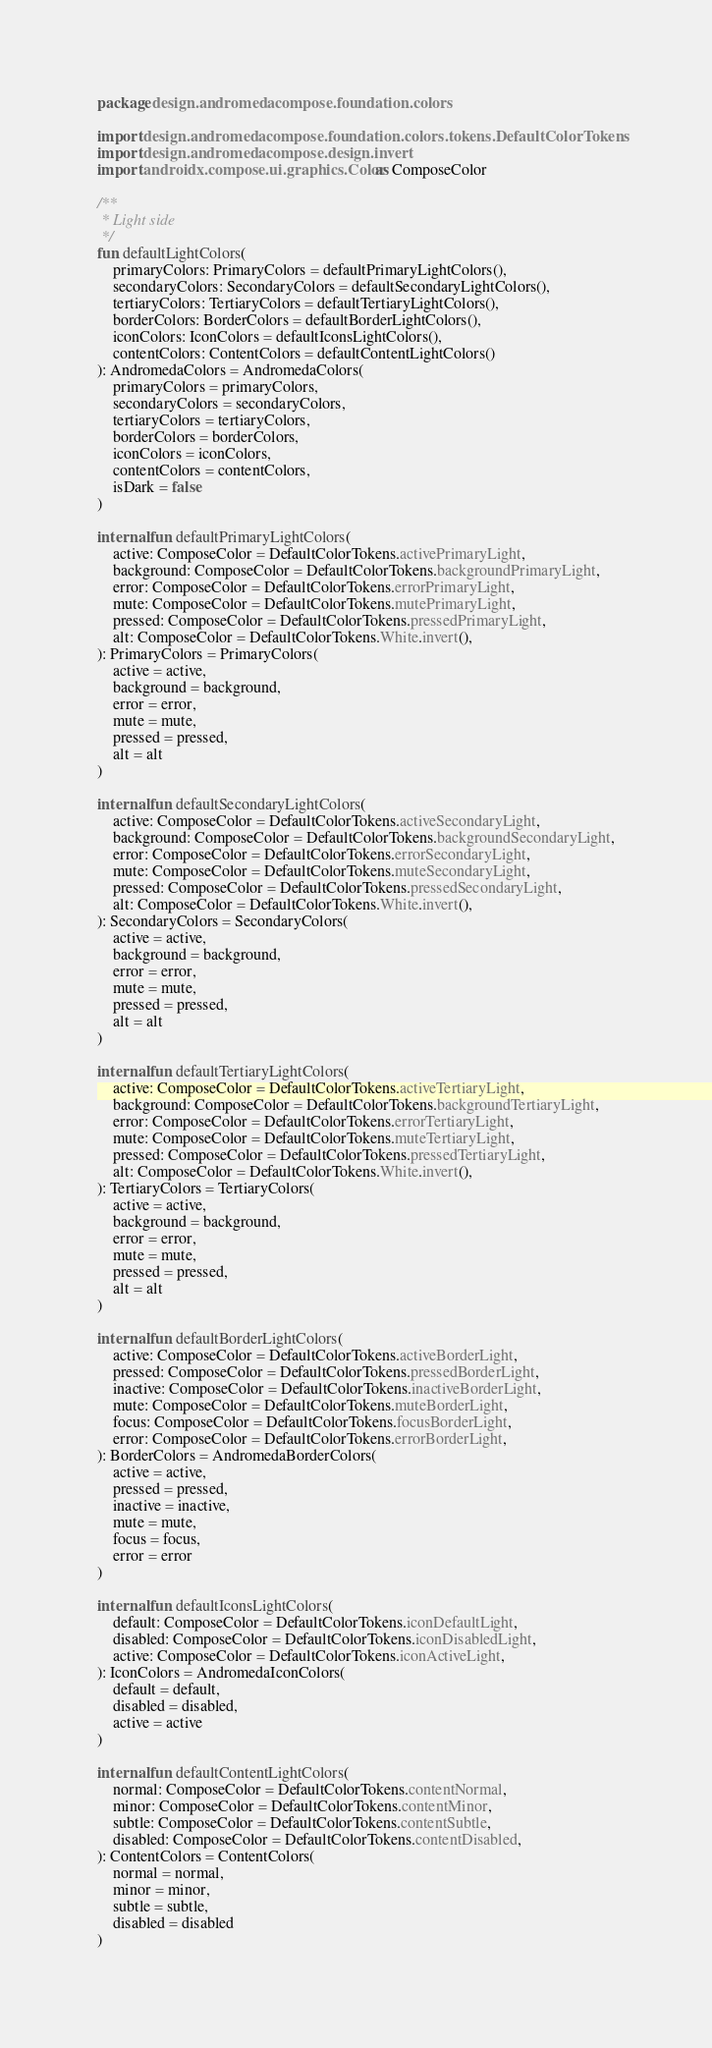<code> <loc_0><loc_0><loc_500><loc_500><_Kotlin_>package design.andromedacompose.foundation.colors

import design.andromedacompose.foundation.colors.tokens.DefaultColorTokens
import design.andromedacompose.design.invert
import androidx.compose.ui.graphics.Color as ComposeColor

/**
 * Light side
 */
fun defaultLightColors(
    primaryColors: PrimaryColors = defaultPrimaryLightColors(),
    secondaryColors: SecondaryColors = defaultSecondaryLightColors(),
    tertiaryColors: TertiaryColors = defaultTertiaryLightColors(),
    borderColors: BorderColors = defaultBorderLightColors(),
    iconColors: IconColors = defaultIconsLightColors(),
    contentColors: ContentColors = defaultContentLightColors()
): AndromedaColors = AndromedaColors(
    primaryColors = primaryColors,
    secondaryColors = secondaryColors,
    tertiaryColors = tertiaryColors,
    borderColors = borderColors,
    iconColors = iconColors,
    contentColors = contentColors,
    isDark = false
)

internal fun defaultPrimaryLightColors(
    active: ComposeColor = DefaultColorTokens.activePrimaryLight,
    background: ComposeColor = DefaultColorTokens.backgroundPrimaryLight,
    error: ComposeColor = DefaultColorTokens.errorPrimaryLight,
    mute: ComposeColor = DefaultColorTokens.mutePrimaryLight,
    pressed: ComposeColor = DefaultColorTokens.pressedPrimaryLight,
    alt: ComposeColor = DefaultColorTokens.White.invert(),
): PrimaryColors = PrimaryColors(
    active = active,
    background = background,
    error = error,
    mute = mute,
    pressed = pressed,
    alt = alt
)

internal fun defaultSecondaryLightColors(
    active: ComposeColor = DefaultColorTokens.activeSecondaryLight,
    background: ComposeColor = DefaultColorTokens.backgroundSecondaryLight,
    error: ComposeColor = DefaultColorTokens.errorSecondaryLight,
    mute: ComposeColor = DefaultColorTokens.muteSecondaryLight,
    pressed: ComposeColor = DefaultColorTokens.pressedSecondaryLight,
    alt: ComposeColor = DefaultColorTokens.White.invert(),
): SecondaryColors = SecondaryColors(
    active = active,
    background = background,
    error = error,
    mute = mute,
    pressed = pressed,
    alt = alt
)

internal fun defaultTertiaryLightColors(
    active: ComposeColor = DefaultColorTokens.activeTertiaryLight,
    background: ComposeColor = DefaultColorTokens.backgroundTertiaryLight,
    error: ComposeColor = DefaultColorTokens.errorTertiaryLight,
    mute: ComposeColor = DefaultColorTokens.muteTertiaryLight,
    pressed: ComposeColor = DefaultColorTokens.pressedTertiaryLight,
    alt: ComposeColor = DefaultColorTokens.White.invert(),
): TertiaryColors = TertiaryColors(
    active = active,
    background = background,
    error = error,
    mute = mute,
    pressed = pressed,
    alt = alt
)

internal fun defaultBorderLightColors(
    active: ComposeColor = DefaultColorTokens.activeBorderLight,
    pressed: ComposeColor = DefaultColorTokens.pressedBorderLight,
    inactive: ComposeColor = DefaultColorTokens.inactiveBorderLight,
    mute: ComposeColor = DefaultColorTokens.muteBorderLight,
    focus: ComposeColor = DefaultColorTokens.focusBorderLight,
    error: ComposeColor = DefaultColorTokens.errorBorderLight,
): BorderColors = AndromedaBorderColors(
    active = active,
    pressed = pressed,
    inactive = inactive,
    mute = mute,
    focus = focus,
    error = error
)

internal fun defaultIconsLightColors(
    default: ComposeColor = DefaultColorTokens.iconDefaultLight,
    disabled: ComposeColor = DefaultColorTokens.iconDisabledLight,
    active: ComposeColor = DefaultColorTokens.iconActiveLight,
): IconColors = AndromedaIconColors(
    default = default,
    disabled = disabled,
    active = active
)

internal fun defaultContentLightColors(
    normal: ComposeColor = DefaultColorTokens.contentNormal,
    minor: ComposeColor = DefaultColorTokens.contentMinor,
    subtle: ComposeColor = DefaultColorTokens.contentSubtle,
    disabled: ComposeColor = DefaultColorTokens.contentDisabled,
): ContentColors = ContentColors(
    normal = normal,
    minor = minor,
    subtle = subtle,
    disabled = disabled
)
</code> 